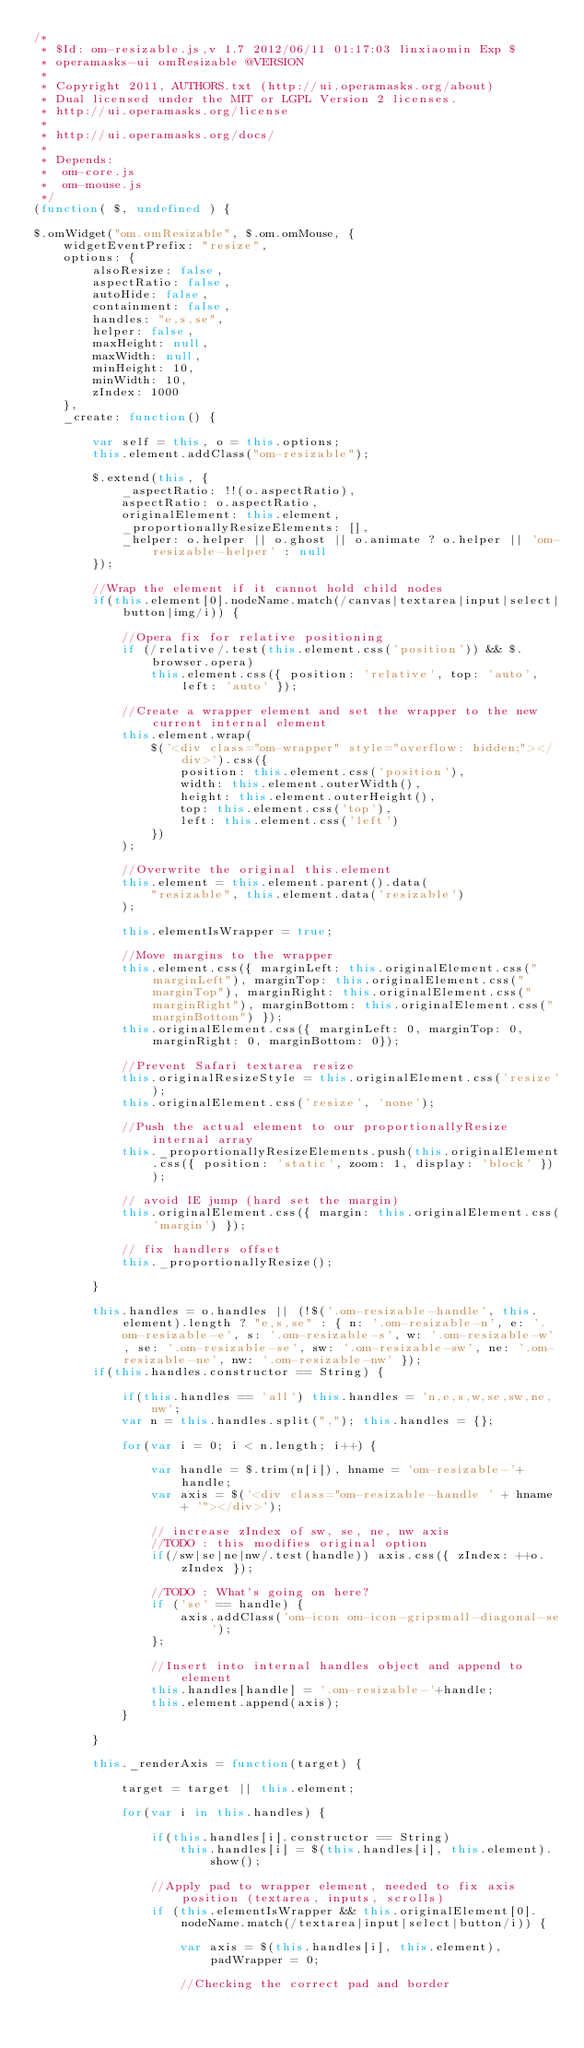<code> <loc_0><loc_0><loc_500><loc_500><_JavaScript_>/*
 * $Id: om-resizable.js,v 1.7 2012/06/11 01:17:03 linxiaomin Exp $
 * operamasks-ui omResizable @VERSION
 *
 * Copyright 2011, AUTHORS.txt (http://ui.operamasks.org/about)
 * Dual licensed under the MIT or LGPL Version 2 licenses.
 * http://ui.operamasks.org/license
 *
 * http://ui.operamasks.org/docs/
 * 
 * Depends:
 *  om-core.js
 *  om-mouse.js
 */
(function( $, undefined ) {

$.omWidget("om.omResizable", $.om.omMouse, {
	widgetEventPrefix: "resize",    
	options: {
		alsoResize: false,
		aspectRatio: false,
		autoHide: false,
		containment: false,
		handles: "e,s,se",
		helper: false,
		maxHeight: null,
		maxWidth: null,
		minHeight: 10,
		minWidth: 10,
		zIndex: 1000
	},
	_create: function() {

		var self = this, o = this.options;
		this.element.addClass("om-resizable");

		$.extend(this, {
			_aspectRatio: !!(o.aspectRatio),
			aspectRatio: o.aspectRatio,
			originalElement: this.element,
			_proportionallyResizeElements: [],
			_helper: o.helper || o.ghost || o.animate ? o.helper || 'om-resizable-helper' : null
		});

		//Wrap the element if it cannot hold child nodes
		if(this.element[0].nodeName.match(/canvas|textarea|input|select|button|img/i)) {

			//Opera fix for relative positioning
			if (/relative/.test(this.element.css('position')) && $.browser.opera)
				this.element.css({ position: 'relative', top: 'auto', left: 'auto' });

			//Create a wrapper element and set the wrapper to the new current internal element
			this.element.wrap(
				$('<div class="om-wrapper" style="overflow: hidden;"></div>').css({
					position: this.element.css('position'),
					width: this.element.outerWidth(),
					height: this.element.outerHeight(),
					top: this.element.css('top'),
					left: this.element.css('left')
				})
			);

			//Overwrite the original this.element
			this.element = this.element.parent().data(
				"resizable", this.element.data('resizable')
			);

			this.elementIsWrapper = true;

			//Move margins to the wrapper
			this.element.css({ marginLeft: this.originalElement.css("marginLeft"), marginTop: this.originalElement.css("marginTop"), marginRight: this.originalElement.css("marginRight"), marginBottom: this.originalElement.css("marginBottom") });
			this.originalElement.css({ marginLeft: 0, marginTop: 0, marginRight: 0, marginBottom: 0});

			//Prevent Safari textarea resize
			this.originalResizeStyle = this.originalElement.css('resize');
			this.originalElement.css('resize', 'none');

			//Push the actual element to our proportionallyResize internal array
			this._proportionallyResizeElements.push(this.originalElement.css({ position: 'static', zoom: 1, display: 'block' }));

			// avoid IE jump (hard set the margin)
			this.originalElement.css({ margin: this.originalElement.css('margin') });

			// fix handlers offset
			this._proportionallyResize();

		}

		this.handles = o.handles || (!$('.om-resizable-handle', this.element).length ? "e,s,se" : { n: '.om-resizable-n', e: '.om-resizable-e', s: '.om-resizable-s', w: '.om-resizable-w', se: '.om-resizable-se', sw: '.om-resizable-sw', ne: '.om-resizable-ne', nw: '.om-resizable-nw' });
		if(this.handles.constructor == String) {

			if(this.handles == 'all') this.handles = 'n,e,s,w,se,sw,ne,nw';
			var n = this.handles.split(","); this.handles = {};

			for(var i = 0; i < n.length; i++) {

				var handle = $.trim(n[i]), hname = 'om-resizable-'+handle;
				var axis = $('<div class="om-resizable-handle ' + hname + '"></div>');

				// increase zIndex of sw, se, ne, nw axis
				//TODO : this modifies original option
				if(/sw|se|ne|nw/.test(handle)) axis.css({ zIndex: ++o.zIndex });

				//TODO : What's going on here?
				if ('se' == handle) {
					axis.addClass('om-icon om-icon-gripsmall-diagonal-se');
				};

				//Insert into internal handles object and append to element
				this.handles[handle] = '.om-resizable-'+handle;
				this.element.append(axis);
			}

		}

		this._renderAxis = function(target) {

			target = target || this.element;

			for(var i in this.handles) {

				if(this.handles[i].constructor == String)
					this.handles[i] = $(this.handles[i], this.element).show();

				//Apply pad to wrapper element, needed to fix axis position (textarea, inputs, scrolls)
				if (this.elementIsWrapper && this.originalElement[0].nodeName.match(/textarea|input|select|button/i)) {

					var axis = $(this.handles[i], this.element), padWrapper = 0;

					//Checking the correct pad and border</code> 